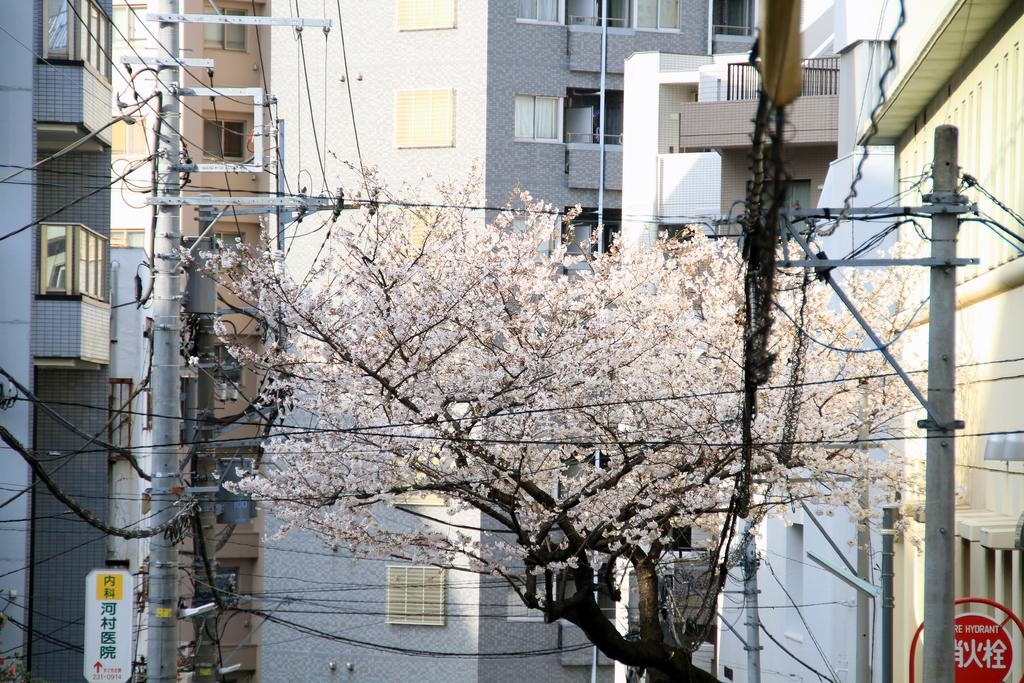What type of structures are present in the image? There are buildings in the image. What feature do the buildings have? The buildings have windows. What natural element can be seen in the image? There is a tree in the image. What man-made object is present in the image? There is an electric pole in the image. What is connected to the electric pole? There are electric wires in the image. What type of sign or notice is visible in the image? There is a board in the image. What type of barrier is present in the image? There is a fence in the image. How many hydrants are visible in the image? There are no hydrants present in the image. What type of mailbox is located near the fence in the image? There is no mailbox present in the image. 